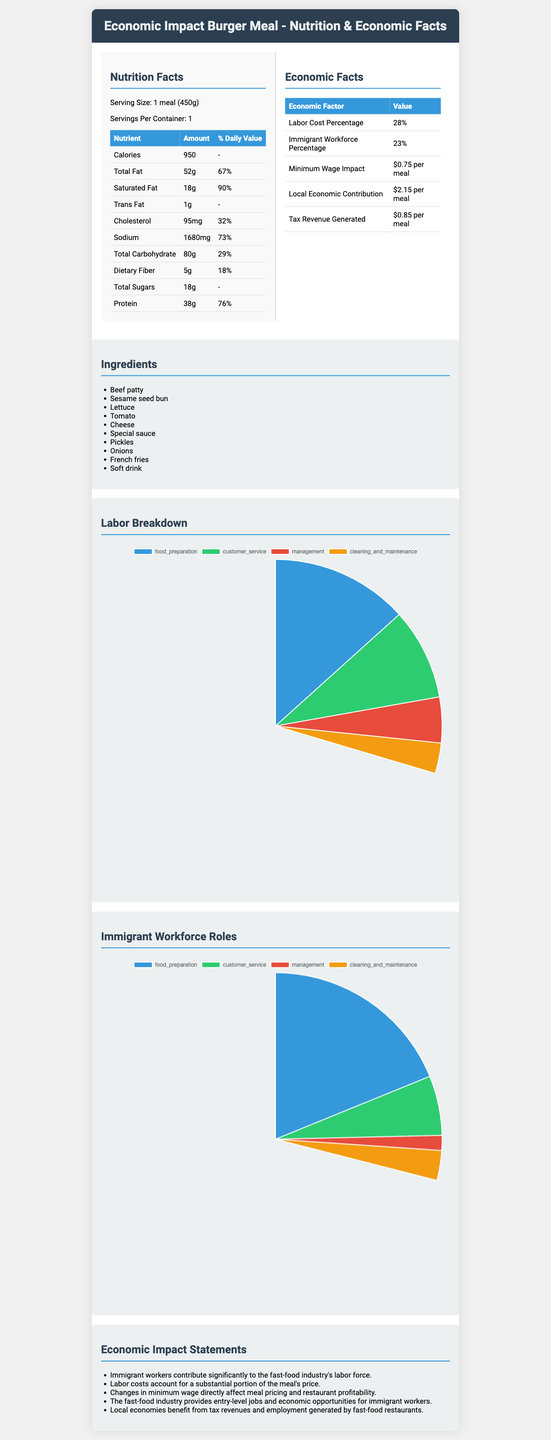what is the serving size of the Economic Impact Burger Meal? The serving size is stated as "1 meal (450g)" in the Nutrition Facts section.
Answer: 1 meal (450g) how many calories are in one meal? The number of calories in one meal is listed under the Nutritional Facts as 950 calories.
Answer: 950 calories what percentage of the meal's labor is attributed to food preparation? In the Labor Breakdown section, it shows that food preparation accounts for 45% of the meal's labor.
Answer: 45% what percentage of the meal is made by immigrant workers in food preparation? The Immigrant Workforce Roles section shows that 65% of the food preparation workforce are immigrant workers.
Answer: 65% what are the ingredients of the Economic Impact Burger Meal? The Ingredients section lists all the components of the meal.
Answer: Beef patty, Sesame seed bun, Lettuce, Tomato, Cheese, Special sauce, Pickles, Onions, French fries, Soft drink how does the local economy benefit from each meal? Under Economic Facts, it is stated that the local economic contribution is $2.15 per meal.
Answer: $2.15 per meal how much tax revenue is generated per meal? The Tax Revenue Generated under Economic Facts is $0.85 per meal.
Answer: $0.85 per meal does the document provide information about the cooking process? The document does not provide any details about the cooking process; it only lists ingredients and nutritional/economic facts.
Answer: No how much does increasing the minimum wage impact the price of each meal? A. $0.50 B. $0.75 C. $1.00 D. $1.25 The Economic Facts section indicates that the minimum wage impact is $0.75 per meal.
Answer: B what is the contribution of tax revenue generated by this meal compared to labor costs? A. Smaller B. Equal C. Larger The tax revenue generated ($0.85 per meal) is smaller than the labor cost percentage.
Answer: A is the percentage of daily value for sodium greater than 70%? The Percentage of Daily Value for sodium is 73%, which is greater than 70%.
Answer: Yes summarize the main economic factors of the Economic Impact Burger Meal. The document outlines several economic factors: labor cost percentage, immigrant workforce participation, local economic contributions, tax revenue, and the effect of minimum wage on pricing.
Answer: The meal encompasses aspects such as labor costs accounting for 28% of the price, a 23% immigrant workforce contribution, local economic benefits of $2.15 per meal, and tax revenues of $0.85 per meal. Minimum wage changes have a measurable impact on meal pricing. what is the protein content of the meal in terms of daily value percentage? The Daily Value Percentage for protein is listed as 76%.
Answer: 76% how much dietary fiber does the meal contain? The amount of dietary fiber is listed under Nutritional Facts as 5 grams.
Answer: 5 grams how many roles in food preparation are held by immigrant workers? The Immigrant Workforce Roles section shows 65% of food preparation roles are held by immigrant workers.
Answer: 65% does the document mention any benefits of the special sauce? The document lists ingredients but does not mention specific benefits of the special sauce.
Answer: No, not enough information 